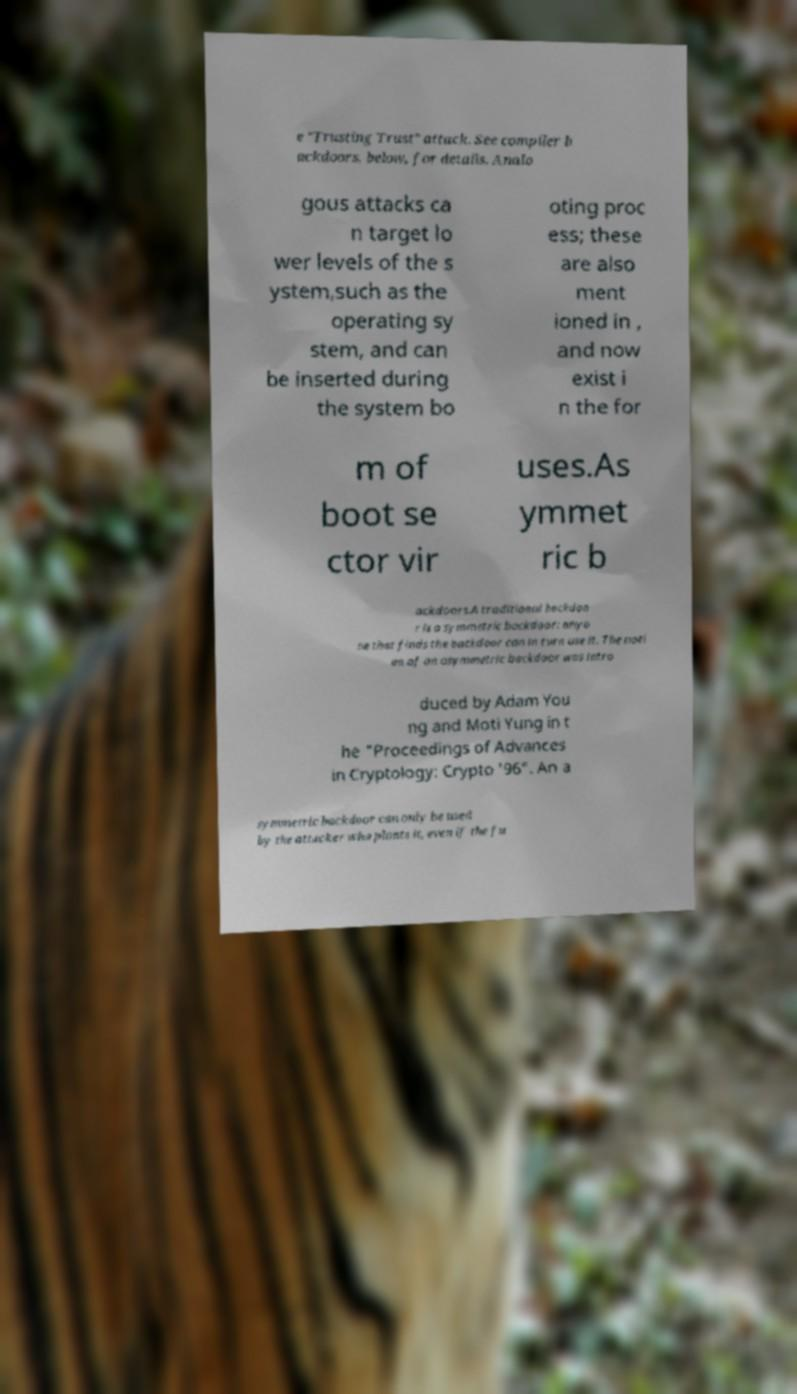Can you accurately transcribe the text from the provided image for me? e "Trusting Trust" attack. See compiler b ackdoors, below, for details. Analo gous attacks ca n target lo wer levels of the s ystem,such as the operating sy stem, and can be inserted during the system bo oting proc ess; these are also ment ioned in , and now exist i n the for m of boot se ctor vir uses.As ymmet ric b ackdoors.A traditional backdoo r is a symmetric backdoor: anyo ne that finds the backdoor can in turn use it. The noti on of an asymmetric backdoor was intro duced by Adam You ng and Moti Yung in t he "Proceedings of Advances in Cryptology: Crypto '96". An a symmetric backdoor can only be used by the attacker who plants it, even if the fu 